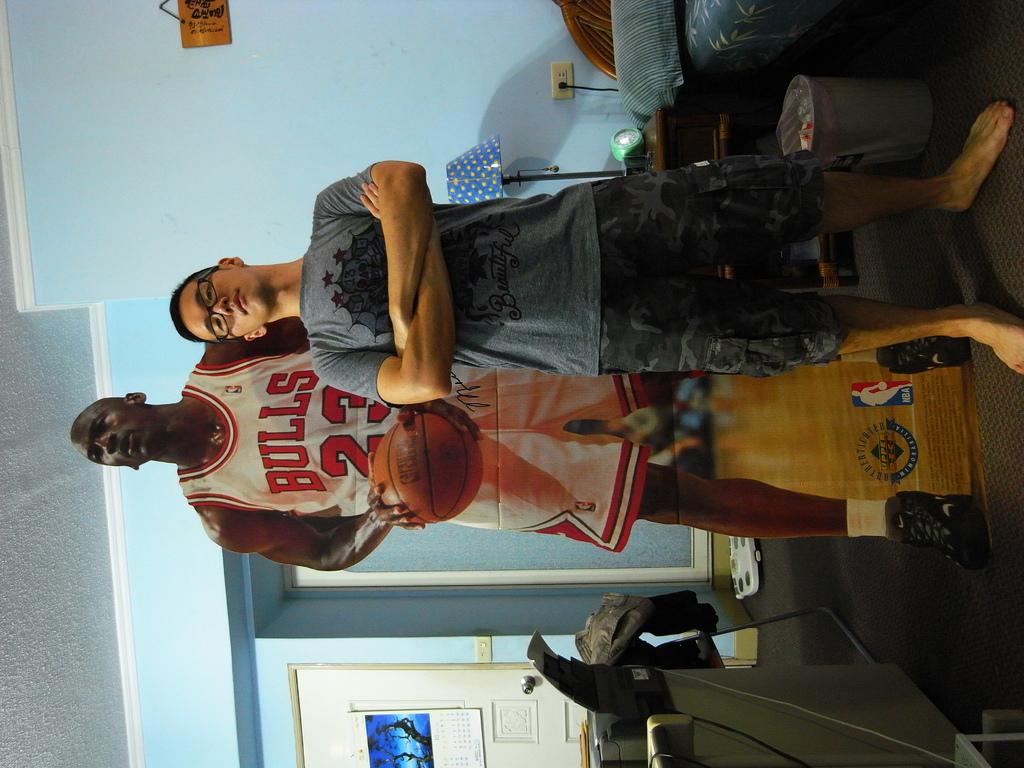What is the name on the logo between the legs of the basketball player?
Provide a short and direct response. Nba. 